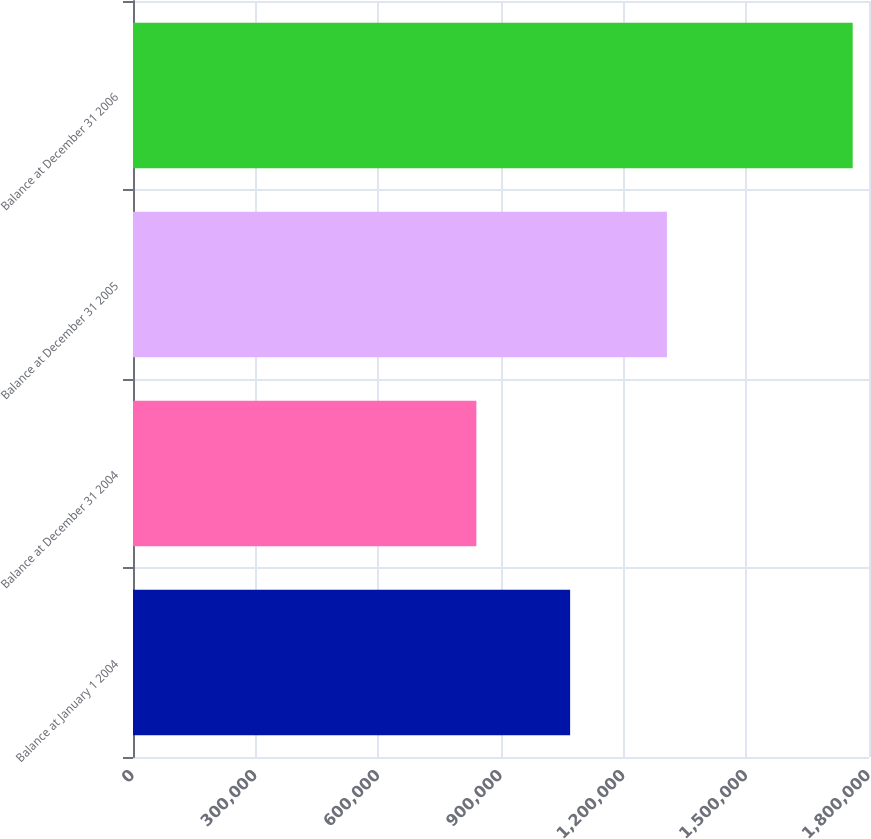<chart> <loc_0><loc_0><loc_500><loc_500><bar_chart><fcel>Balance at January 1 2004<fcel>Balance at December 31 2004<fcel>Balance at December 31 2005<fcel>Balance at December 31 2006<nl><fcel>1.06905e+06<fcel>839737<fcel>1.30585e+06<fcel>1.76012e+06<nl></chart> 